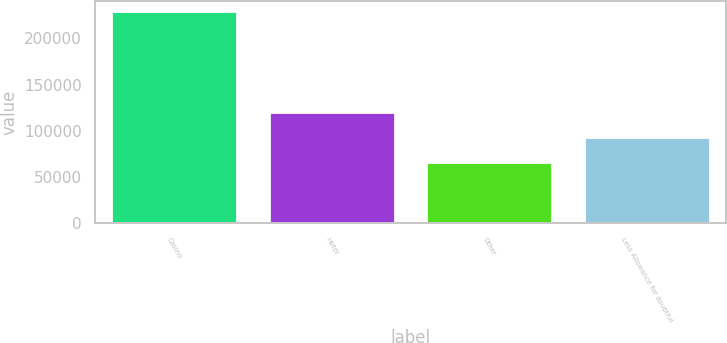<chart> <loc_0><loc_0><loc_500><loc_500><bar_chart><fcel>Casino<fcel>Hotel<fcel>Other<fcel>Less Allowance for doubtful<nl><fcel>229318<fcel>119887<fcel>66449<fcel>93760<nl></chart> 